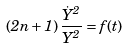Convert formula to latex. <formula><loc_0><loc_0><loc_500><loc_500>\left ( 2 n + 1 \right ) \frac { \dot { Y } ^ { 2 } } { Y ^ { 2 } } = f ( t )</formula> 